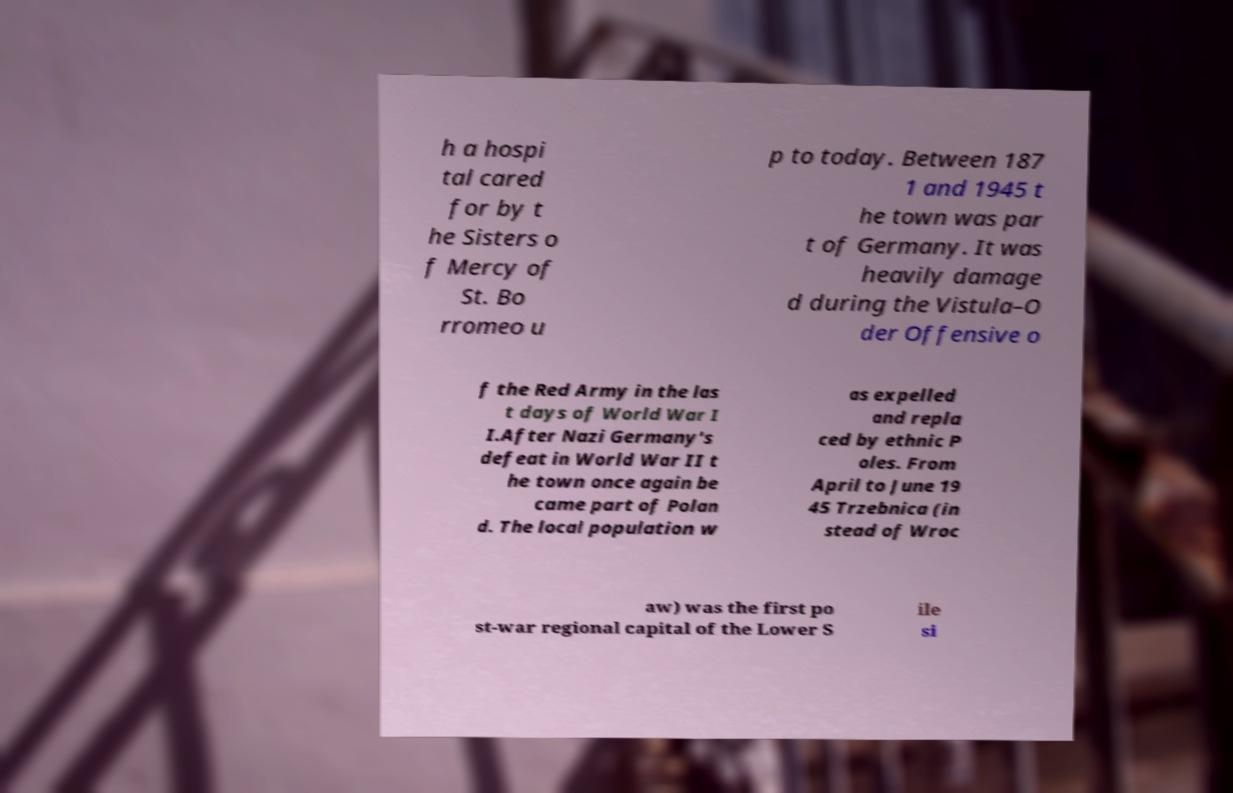Please read and relay the text visible in this image. What does it say? h a hospi tal cared for by t he Sisters o f Mercy of St. Bo rromeo u p to today. Between 187 1 and 1945 t he town was par t of Germany. It was heavily damage d during the Vistula–O der Offensive o f the Red Army in the las t days of World War I I.After Nazi Germany's defeat in World War II t he town once again be came part of Polan d. The local population w as expelled and repla ced by ethnic P oles. From April to June 19 45 Trzebnica (in stead of Wroc aw) was the first po st-war regional capital of the Lower S ile si 